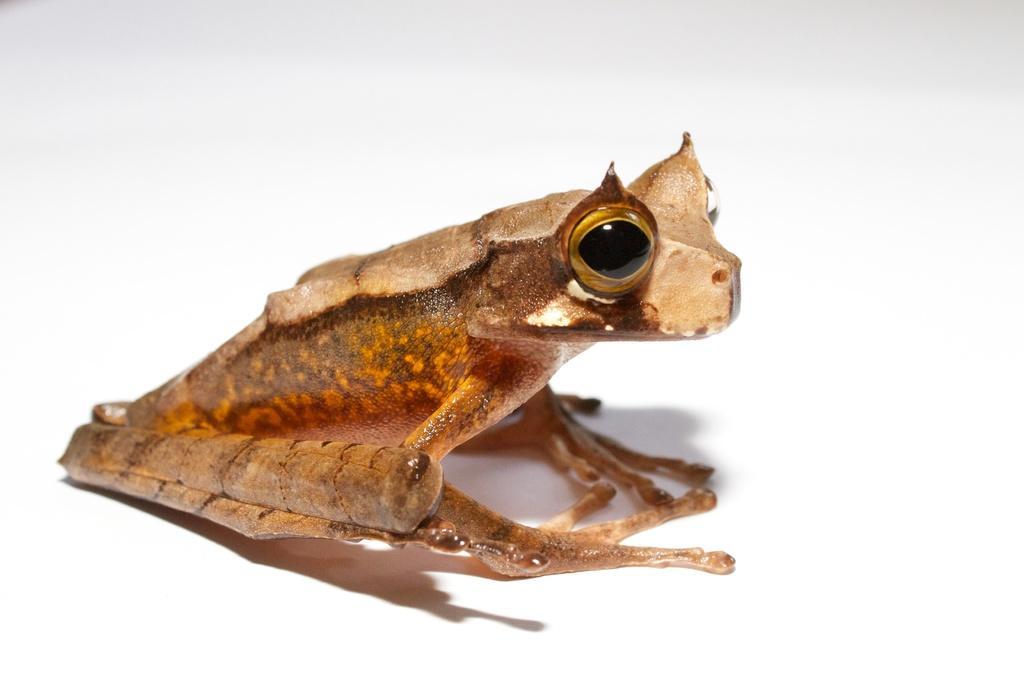Please provide a concise description of this image. In this image I can see the frog in cream and brown color and I can see the white color background. 